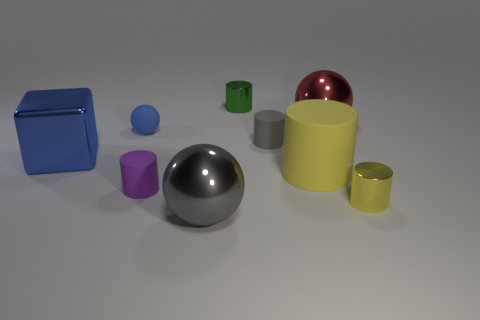Is the material of the tiny yellow object the same as the small thing that is on the left side of the purple matte cylinder?
Give a very brief answer. No. What number of tiny green rubber cylinders are there?
Offer a very short reply. 0. What is the size of the shiny ball that is on the right side of the big shiny thing in front of the yellow shiny cylinder that is in front of the big yellow rubber object?
Your answer should be very brief. Large. Does the block have the same color as the small rubber ball?
Make the answer very short. Yes. There is a big gray thing; what number of tiny things are right of it?
Keep it short and to the point. 3. Are there an equal number of tiny yellow things that are behind the large rubber thing and yellow metal spheres?
Offer a very short reply. Yes. How many objects are green spheres or blue matte spheres?
Your answer should be very brief. 1. Are there any other things that have the same shape as the large blue metallic thing?
Provide a short and direct response. No. There is a large gray thing on the right side of the small thing to the left of the tiny purple thing; what shape is it?
Make the answer very short. Sphere. There is a small gray thing that is the same material as the purple thing; what is its shape?
Offer a very short reply. Cylinder. 